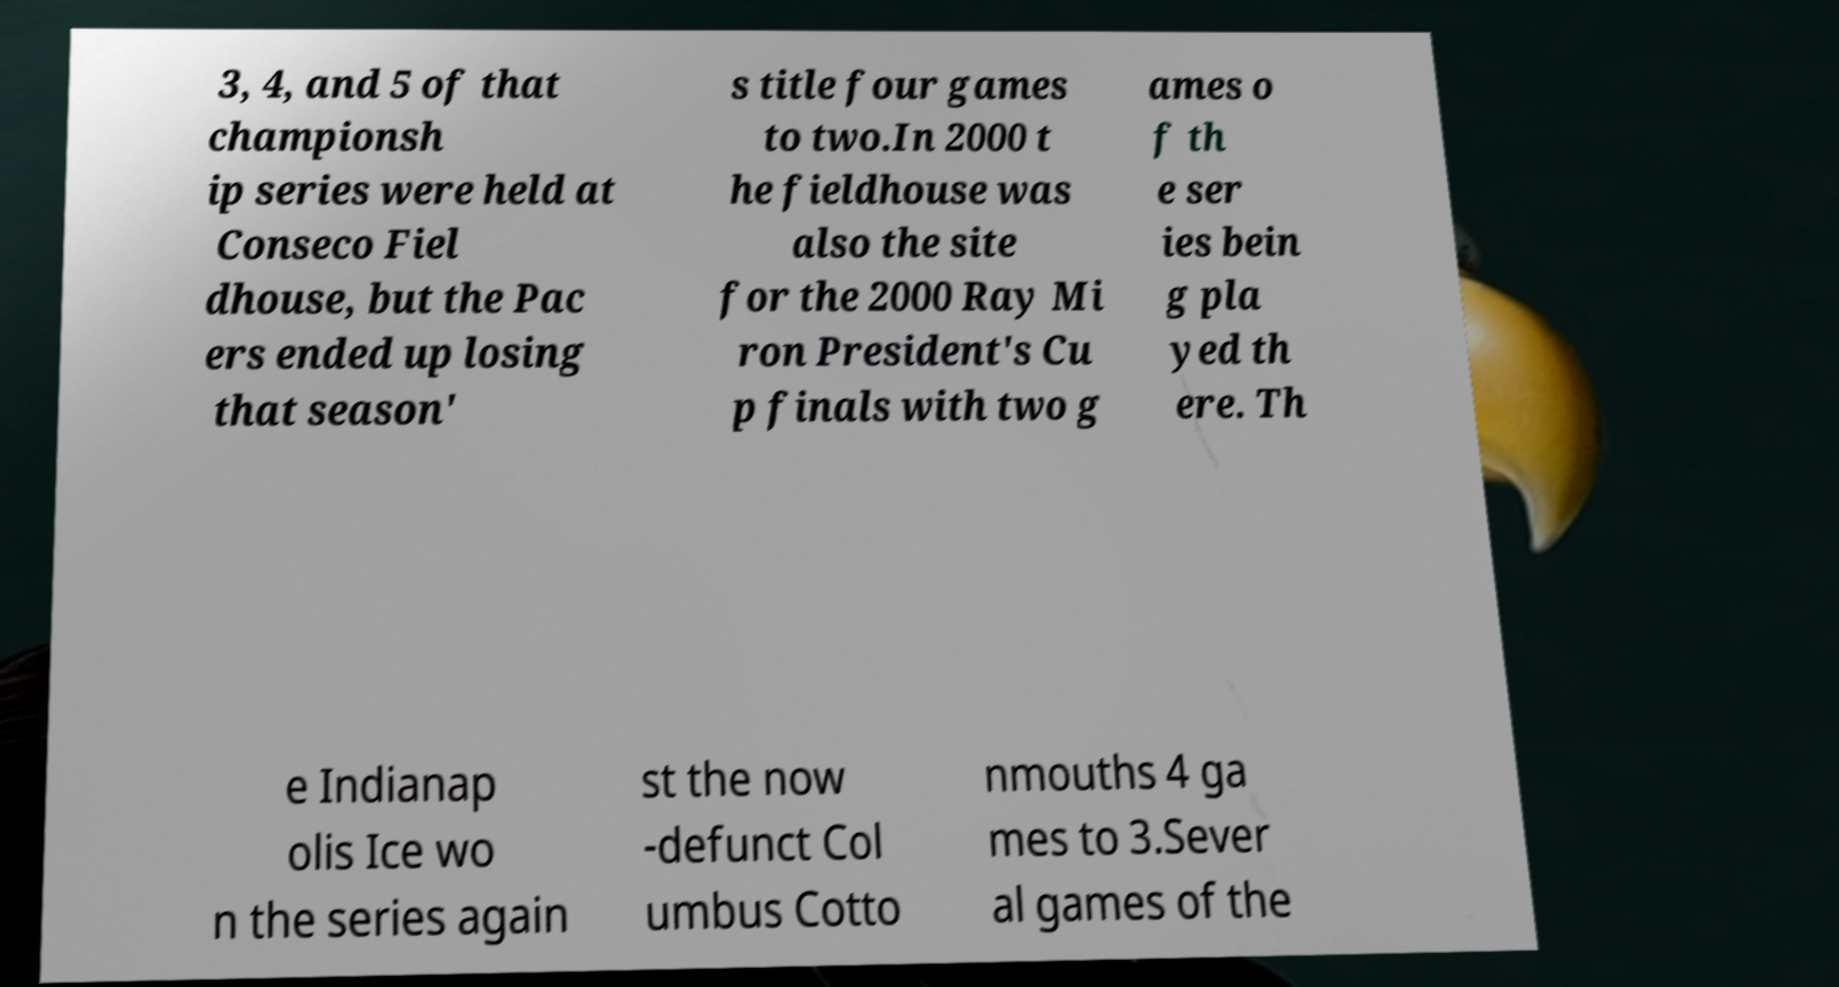Could you extract and type out the text from this image? 3, 4, and 5 of that championsh ip series were held at Conseco Fiel dhouse, but the Pac ers ended up losing that season' s title four games to two.In 2000 t he fieldhouse was also the site for the 2000 Ray Mi ron President's Cu p finals with two g ames o f th e ser ies bein g pla yed th ere. Th e Indianap olis Ice wo n the series again st the now -defunct Col umbus Cotto nmouths 4 ga mes to 3.Sever al games of the 